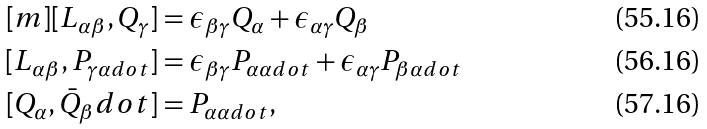<formula> <loc_0><loc_0><loc_500><loc_500>[ m ] [ L _ { \alpha \beta } , Q _ { \gamma } ] & = \epsilon _ { \beta \gamma } Q _ { \alpha } + \epsilon _ { \alpha \gamma } Q _ { \beta } \\ [ L _ { \alpha \beta } , P _ { \gamma \alpha d o t } ] & = \epsilon _ { \beta \gamma } P _ { \alpha \alpha d o t } + \epsilon _ { \alpha \gamma } P _ { \beta \alpha d o t } \\ [ Q _ { \alpha } , \bar { Q } _ { \beta } d o t ] & = P _ { \alpha \alpha d o t } ,</formula> 